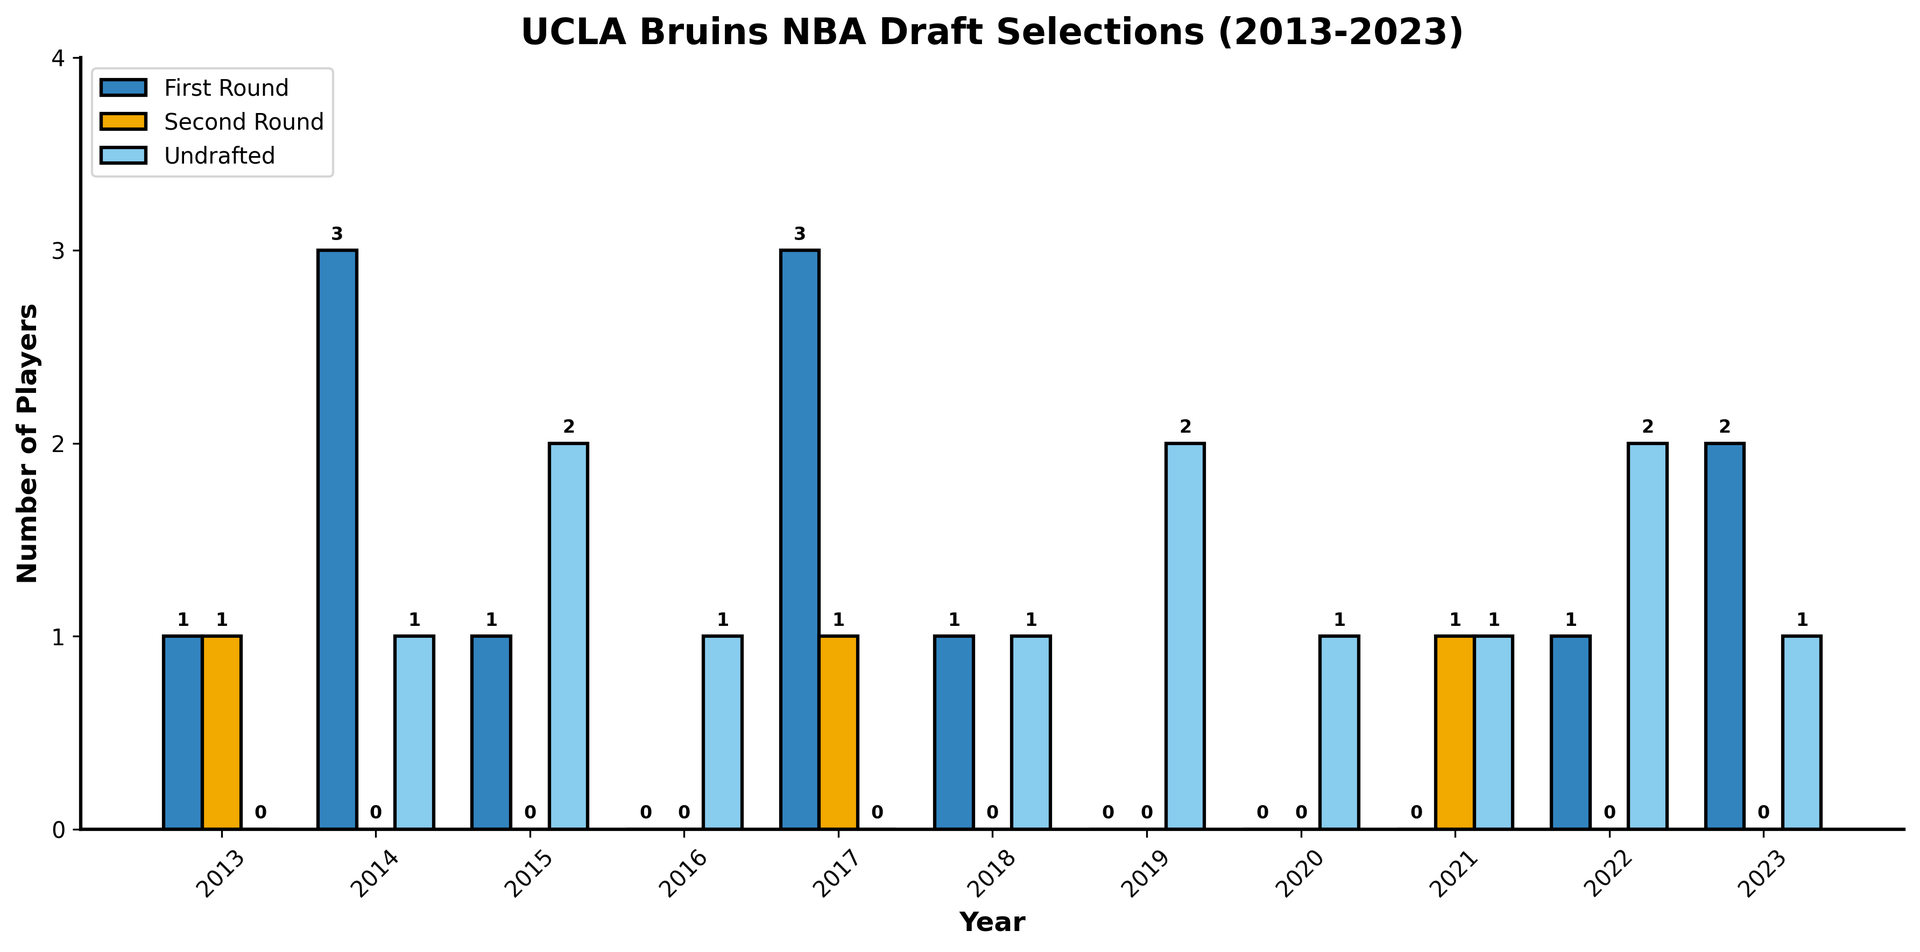What's the total number of first-round picks in 2017 and 2023 combined? Look at the heights of the blue bars representing first-round picks for the years 2017 and 2023, respectively. For 2017, the blue bar height is 3. For 2023, the blue bar height is 2. Summing these values gives 3 + 2.
Answer: 5 Which year had the most second-round draft selections? Examine the heights of all the orange bars corresponding to second-round picks across each year. The tallest orange bar occurs in 2013 and 2021, with a height of 1. Thus, both 2013 and 2021 had the most second-round picks.
Answer: 2013 and 2021 In which year were there the highest number of undrafted players? Check the heights of the light blue bars which represent undrafted players for each year. The tallest light blue bar corresponds to 2022 and has a height of 2, indicating the highest number of undrafted players.
Answer: 2022 How many years had zero first-round draft selections? Identify the years where the blue bars, denoting first-round picks, have a height of 0. These occur in 2016, 2019, 2020, and 2021, giving a total of 4 years.
Answer: 4 Compare the total undrafted players to the total second-round picks over the decade. Which is greater? Sum the heights of the light blue bars (undrafted players) and orange bars (second-round picks). The total undrafted players is 0+1+2+1+0+1+2+1+1+2+1 = 12, and the total second-round picks is 1+0+0+0+1+0+0+0+1+0+0 = 3. Comparing these, 12 is greater than 3.
Answer: Undrafted players What is the average number of first-round picks per year over the decade? Sum the heights of all blue bars and divide by the number of years (11). The total sum is 1+3+1+0+3+1+0+0+0+1+2 = 12. Dividing by 11 gives 12 / 11.
Answer: 1.09 Which year had an equal number of first-round and second-round picks? Look for a year where the heights of the blue and orange bars are the same. In 2013, both the blue and orange bars have a height of 1.
Answer: 2013 Identify the year with exactly one player drafted in each category (first-round, second-round, and undrafted). Look for the year where the blue, orange, and light blue bars each have a height of 1. No such year exists where all three categories have exactly one player drafted.
Answer: None 